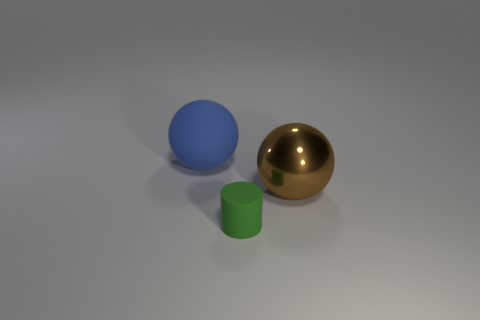What number of green objects are rubber cylinders or big shiny balls?
Your answer should be very brief. 1. Do the big ball that is on the right side of the tiny matte thing and the small matte cylinder on the right side of the rubber ball have the same color?
Offer a very short reply. No. There is a big thing to the right of the tiny cylinder that is on the right side of the large thing on the left side of the metal ball; what is its color?
Make the answer very short. Brown. Are there any big blue rubber objects that are on the right side of the ball that is to the left of the brown ball?
Your response must be concise. No. There is a object to the left of the small rubber cylinder; is it the same shape as the metal thing?
Your answer should be compact. Yes. Is there any other thing that is the same shape as the brown metallic thing?
Keep it short and to the point. Yes. What number of spheres are large objects or metallic things?
Give a very brief answer. 2. What number of tiny green rubber things are there?
Your answer should be compact. 1. There is a rubber object left of the rubber object that is in front of the brown sphere; what size is it?
Offer a terse response. Large. What number of other things are there of the same size as the rubber ball?
Your response must be concise. 1. 